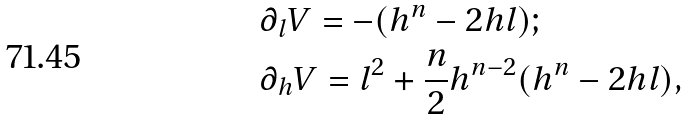Convert formula to latex. <formula><loc_0><loc_0><loc_500><loc_500>& \partial _ { l } V = - ( h ^ { n } - 2 h l ) ; \\ & \partial _ { h } V = l ^ { 2 } + \frac { n } { 2 } h ^ { n - 2 } ( h ^ { n } - 2 h l ) ,</formula> 